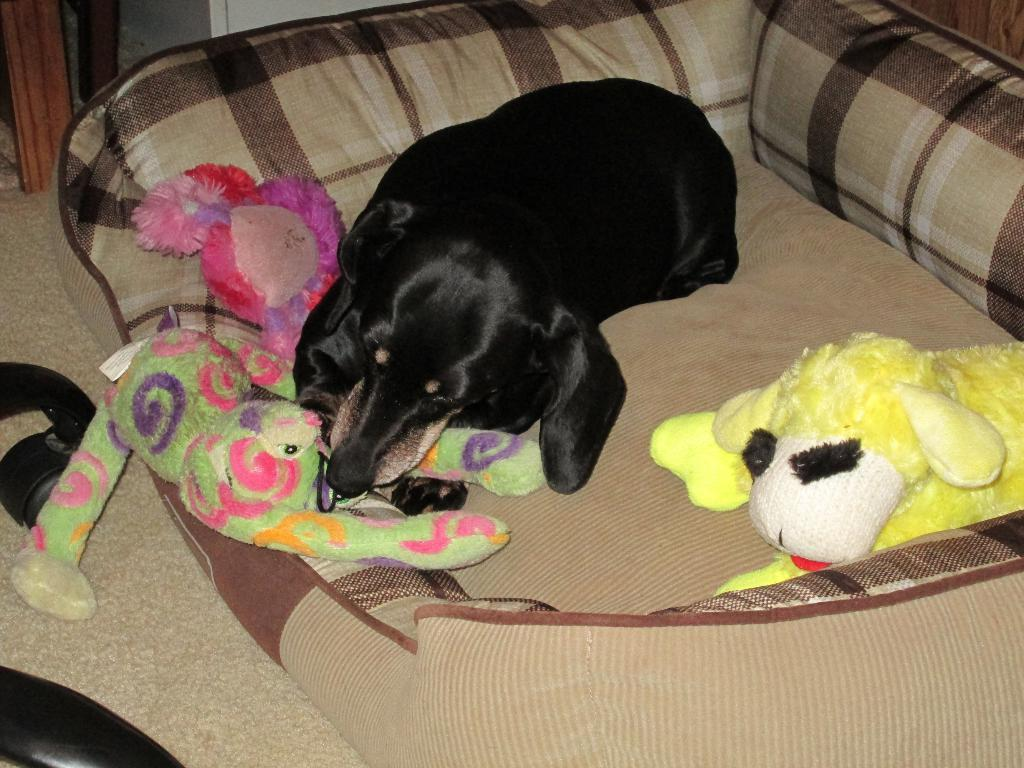What type of animal is in the image? There is a black dog in the image. Where is the dog located? The dog is laying on a sofa. What else can be seen on the sofa? There are toys on the sofa. What color is the sofa? The sofa is cream-colored. What is present on the left side of the image? There is a cream-colored curtain on the left side of the image. What type of memory does the dog have in the image? There is no indication of the dog having any memory in the image, as it is a static photograph. 